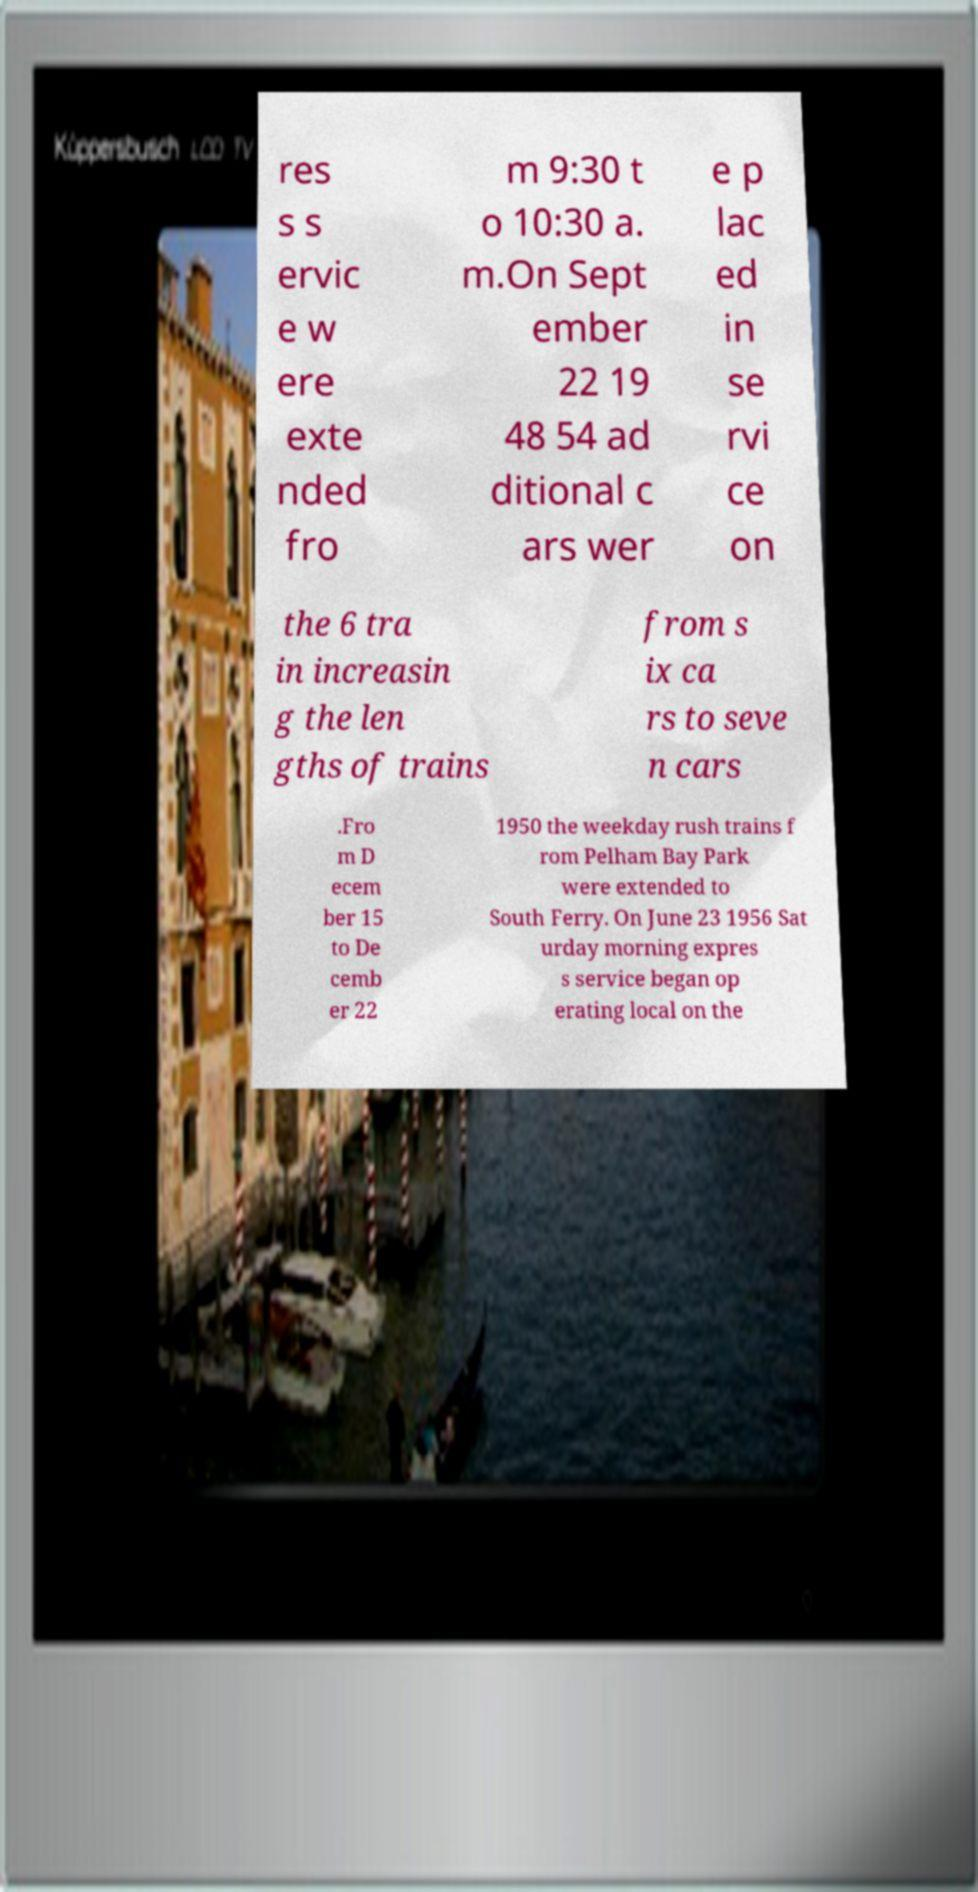There's text embedded in this image that I need extracted. Can you transcribe it verbatim? res s s ervic e w ere exte nded fro m 9:30 t o 10:30 a. m.On Sept ember 22 19 48 54 ad ditional c ars wer e p lac ed in se rvi ce on the 6 tra in increasin g the len gths of trains from s ix ca rs to seve n cars .Fro m D ecem ber 15 to De cemb er 22 1950 the weekday rush trains f rom Pelham Bay Park were extended to South Ferry. On June 23 1956 Sat urday morning expres s service began op erating local on the 